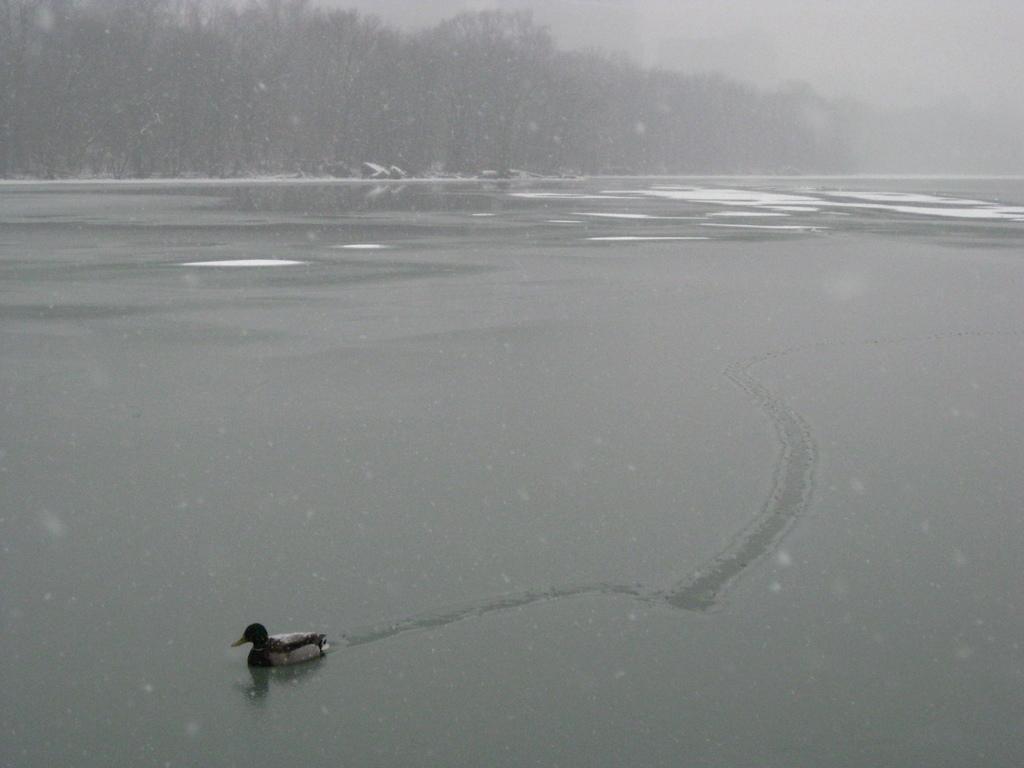How would you summarize this image in a sentence or two? In this image there is a water surface on that there is a duck swimming, in the background there are trees. 